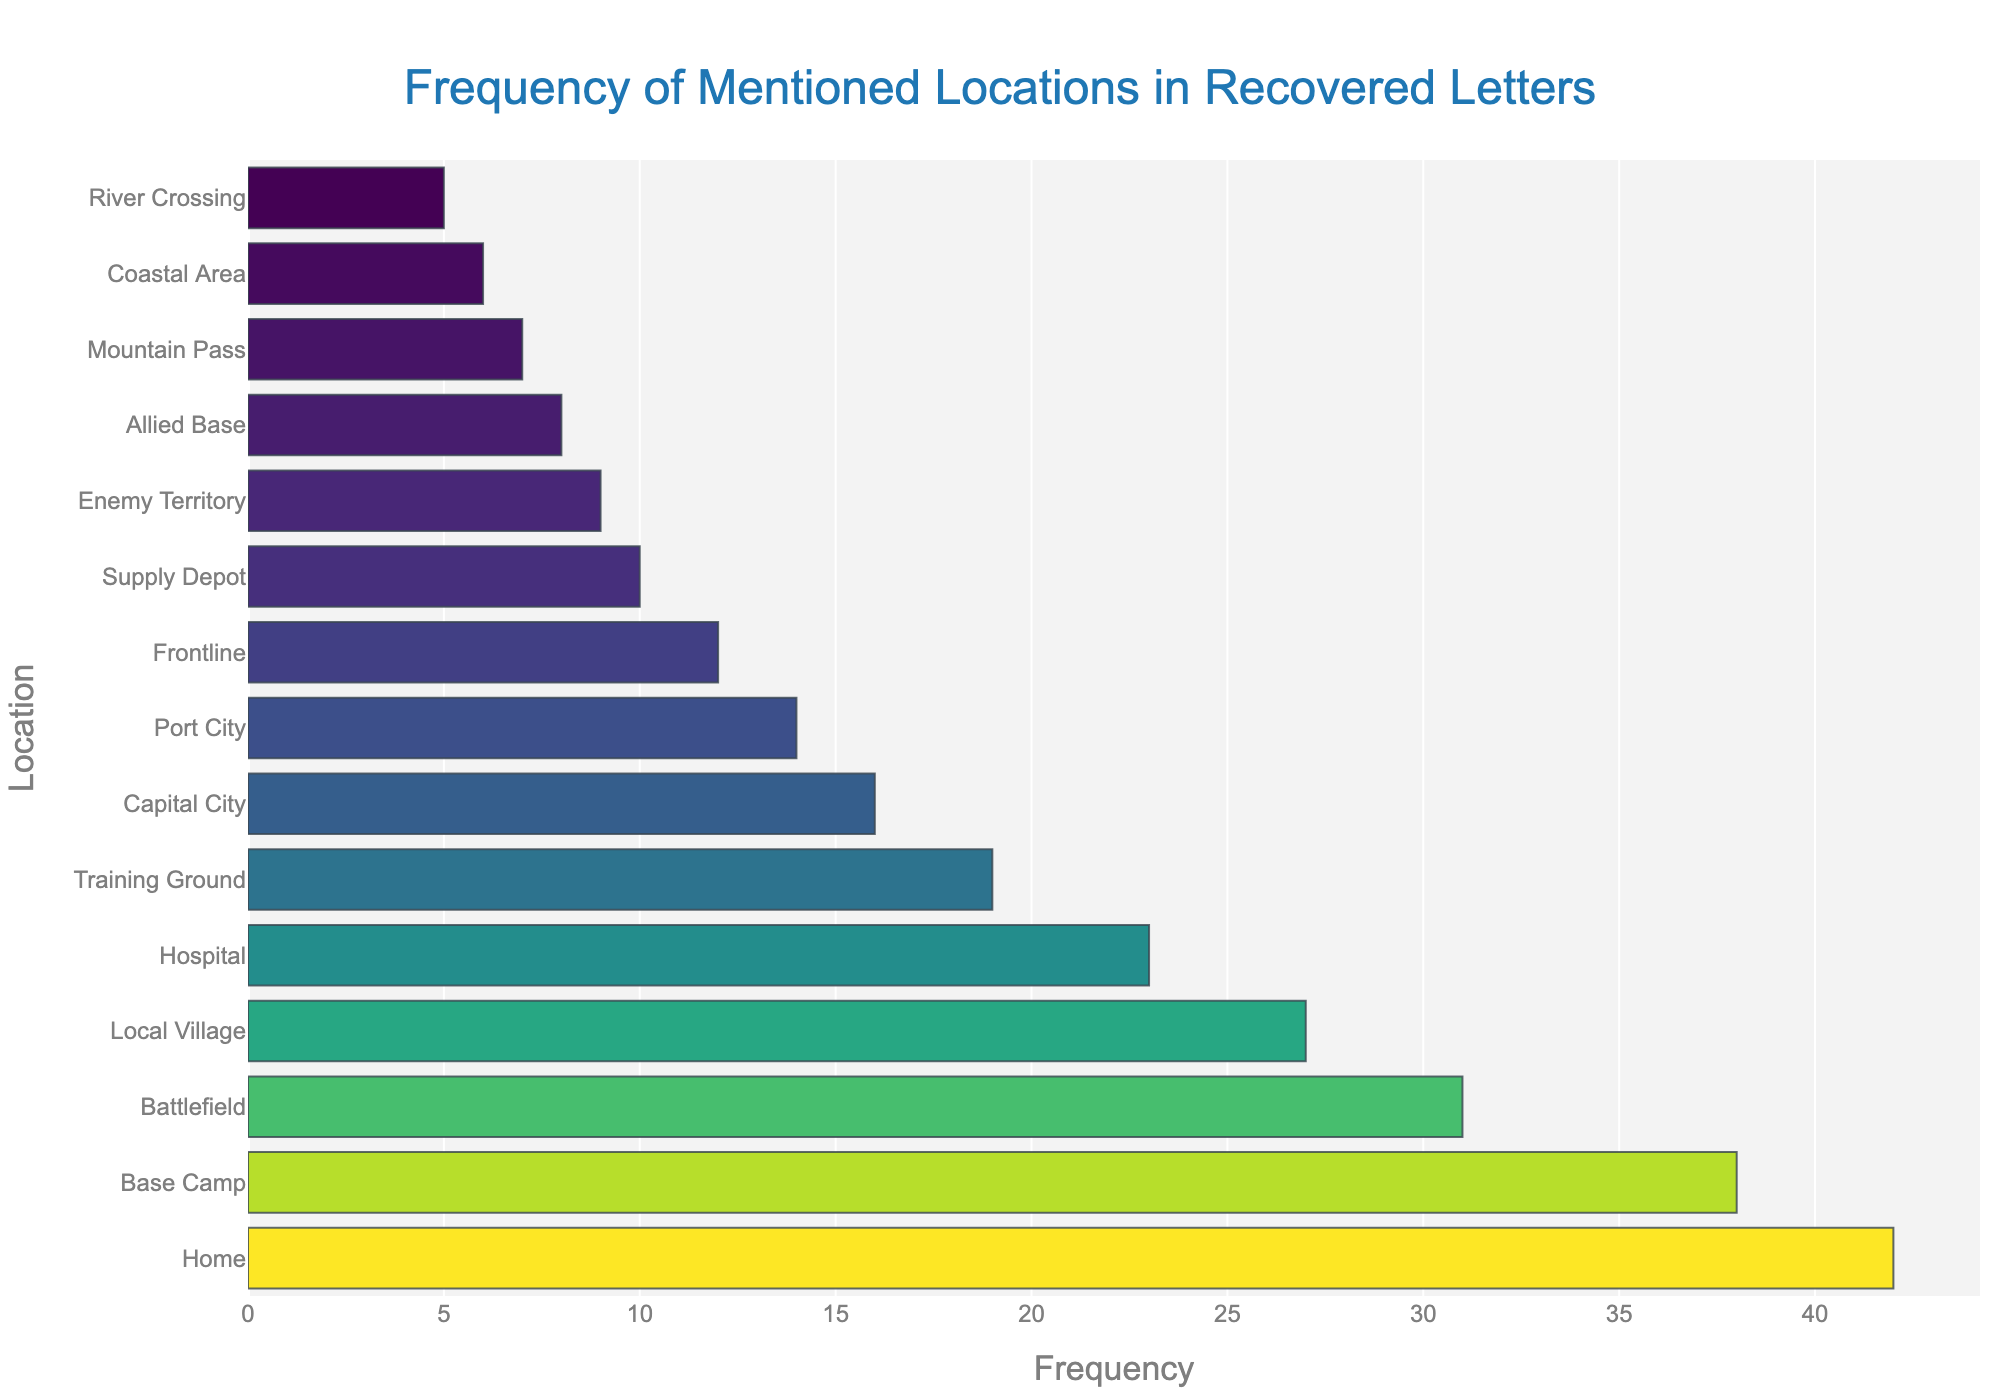Which location is mentioned the most in the letters? The location that is mentioned the most will have the highest bar in the bar chart. In this case, "Home" has the highest bar with a frequency of 42.
Answer: Home What is the difference in frequency between "Base Camp" and "Battlefield"? To determine the difference, subtract the frequency of "Battlefield" from "Base Camp": 38 - 31 = 7.
Answer: 7 What are the top three most mentioned locations? The top three most mentioned locations will have the highest bars. They are "Home" (42), "Base Camp" (38), and "Battlefield" (31).
Answer: Home, Base Camp, Battlefield Is "Hospital" mentioned more frequently than "Training Ground"? Compare the frequencies of both locations. "Hospital" has a frequency of 23, while "Training Ground" has 19. Since 23 > 19, "Hospital" is mentioned more frequently.
Answer: Yes What is the sum of frequencies for "Local Village" and "Port City"? Add the frequencies of the two locations: Local Village (27) + Port City (14) = 41.
Answer: 41 Which location has a frequency that is closest to 10? Look for the location whose frequency is closest to 10 in value. "Supply Depot" has a frequency of 10.
Answer: Supply Depot How many locations have a frequency greater than 20? Count the number of bars with frequencies higher than 20: Home (42), Base Camp (38), Battlefield (31), Local Village (27), and Hospital (23), which are 5 locations.
Answer: 5 Is "Enemy Territory" mentioned more frequently than "Allied Base"? Compare the frequencies of both locations. Enemy Territory has a frequency of 9, and Allied Base has a frequency of 8. Since 9 > 8, "Enemy Territory" is mentioned more frequently.
Answer: Yes Which location is mentioned the least in the documents? The location mentioned the least will have the lowest bar. In this case, "River Crossing" has the lowest frequency with 5.
Answer: River Crossing 